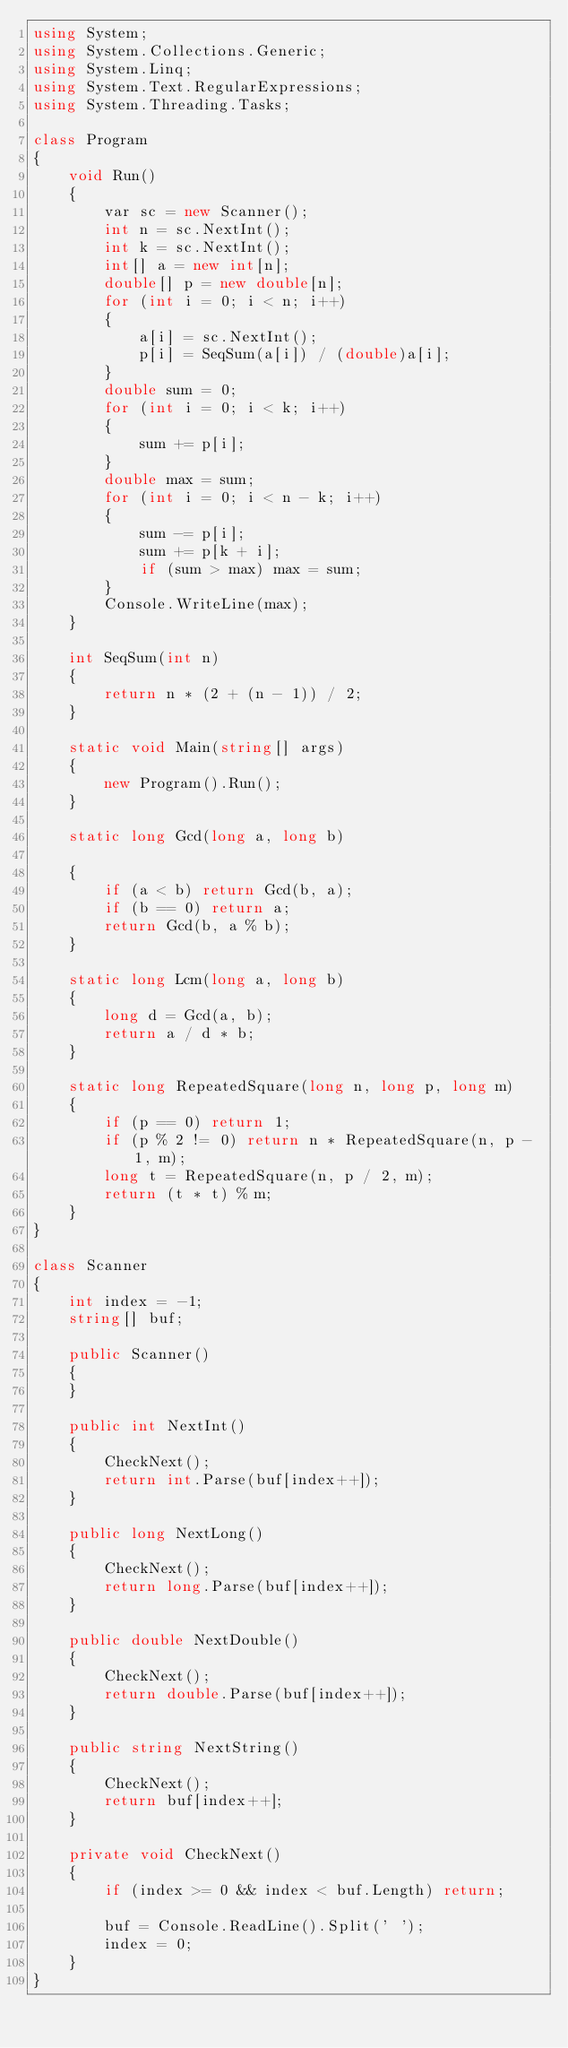<code> <loc_0><loc_0><loc_500><loc_500><_C#_>using System;
using System.Collections.Generic;
using System.Linq;
using System.Text.RegularExpressions;
using System.Threading.Tasks;

class Program
{
    void Run()
    {
        var sc = new Scanner();
        int n = sc.NextInt();
        int k = sc.NextInt();
        int[] a = new int[n];
        double[] p = new double[n];
        for (int i = 0; i < n; i++)
        {
            a[i] = sc.NextInt();
            p[i] = SeqSum(a[i]) / (double)a[i];
        }
        double sum = 0;
        for (int i = 0; i < k; i++)
        {
            sum += p[i];
        }
        double max = sum;
        for (int i = 0; i < n - k; i++)
        {
            sum -= p[i];
            sum += p[k + i];
            if (sum > max) max = sum;
        }
        Console.WriteLine(max);
    }

    int SeqSum(int n)
    {
        return n * (2 + (n - 1)) / 2;
    }

    static void Main(string[] args)
    {
        new Program().Run();
    }

    static long Gcd(long a, long b)

    {
        if (a < b) return Gcd(b, a);
        if (b == 0) return a;
        return Gcd(b, a % b);
    }

    static long Lcm(long a, long b)
    {
        long d = Gcd(a, b);
        return a / d * b;
    }

    static long RepeatedSquare(long n, long p, long m)
    {
        if (p == 0) return 1;
        if (p % 2 != 0) return n * RepeatedSquare(n, p - 1, m);
        long t = RepeatedSquare(n, p / 2, m);
        return (t * t) % m;
    }
}

class Scanner
{
    int index = -1;
    string[] buf;

    public Scanner()
    {
    }

    public int NextInt()
    {
        CheckNext();
        return int.Parse(buf[index++]);
    }

    public long NextLong()
    {
        CheckNext();
        return long.Parse(buf[index++]);
    }

    public double NextDouble()
    {
        CheckNext();
        return double.Parse(buf[index++]);
    }

    public string NextString()
    {
        CheckNext();
        return buf[index++];
    }

    private void CheckNext()
    {
        if (index >= 0 && index < buf.Length) return;

        buf = Console.ReadLine().Split(' ');
        index = 0;
    }
}
</code> 